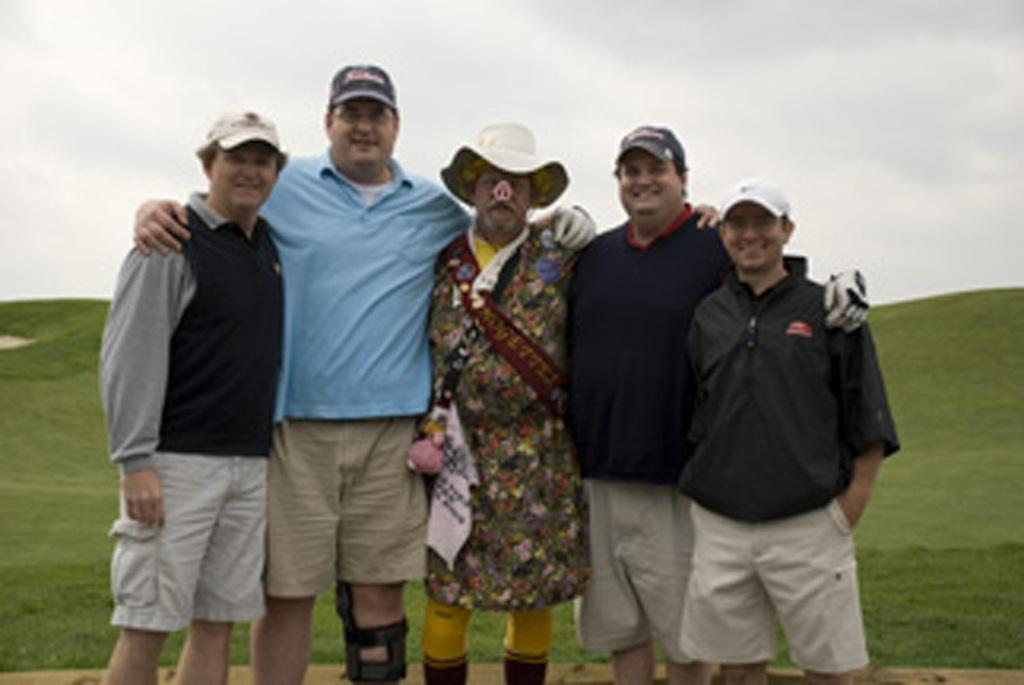Who or what is present in the image? There are people in the image. What is the emotional state of the people in the image? The people are smiling. What type of natural environment is visible in the image? There is grass visible in the image. How many babies are crawling on the grass in the image? There are no babies present in the image; it only features people who are smiling. 